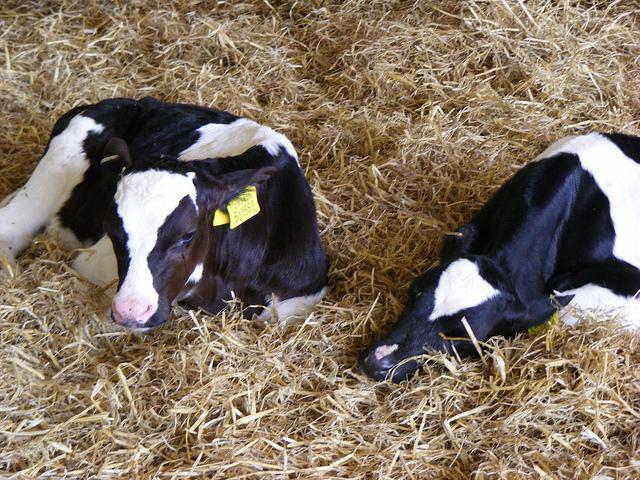How many cows can be seen?
Give a very brief answer. 2. 